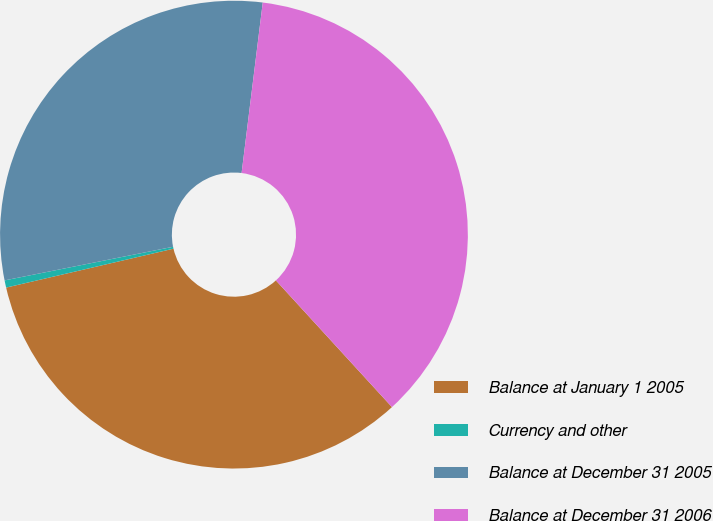Convert chart. <chart><loc_0><loc_0><loc_500><loc_500><pie_chart><fcel>Balance at January 1 2005<fcel>Currency and other<fcel>Balance at December 31 2005<fcel>Balance at December 31 2006<nl><fcel>33.17%<fcel>0.5%<fcel>30.1%<fcel>36.23%<nl></chart> 